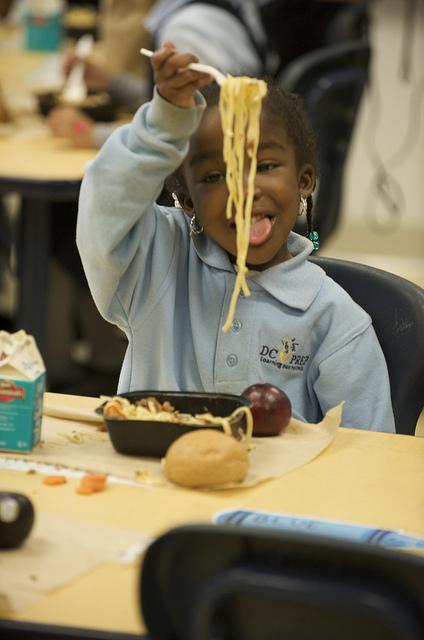What is the child eating?
Answer briefly. Spaghetti. What is the child wearing?
Give a very brief answer. Long sleeve shirt. Does the child look like they're enjoying their lunch?
Concise answer only. Yes. 